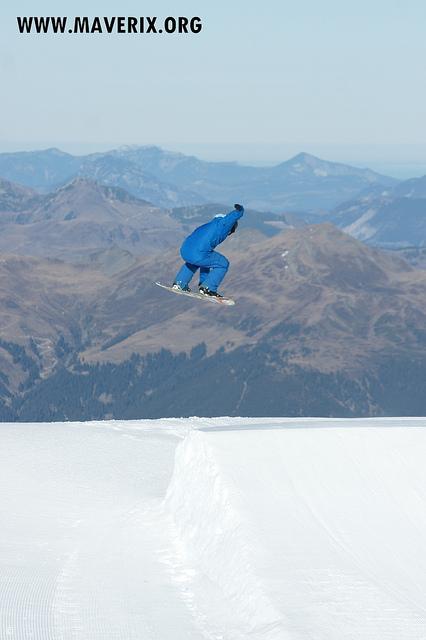Is the man in the air?
Be succinct. Yes. Is there a city pictured in the back?
Short answer required. No. Is it midday?
Give a very brief answer. Yes. What suit is he wearing?
Answer briefly. Ski. What color is the coat?
Be succinct. Blue. Did the man jump before the picture was taken?
Concise answer only. Yes. Is the boy flying?
Keep it brief. No. What activity is this person doing?
Keep it brief. Snowboarding. What color is the man's coat?
Give a very brief answer. Blue. Are there mountains in the picture?
Short answer required. Yes. What color is the snowboard?
Write a very short answer. White. Which website is on this picture?
Short answer required. Wwwmaverixorg. 